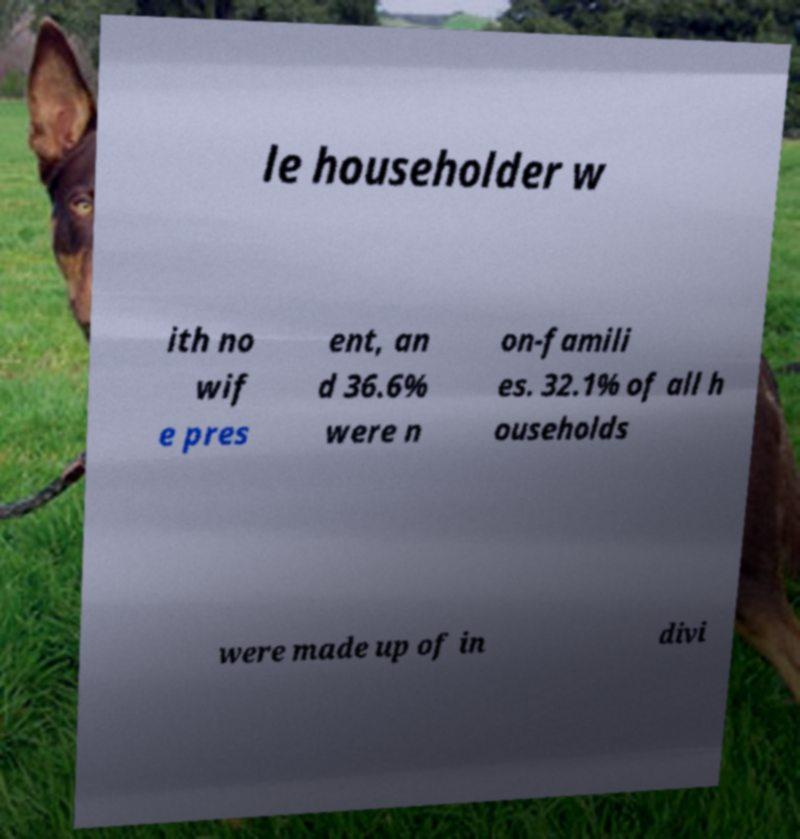There's text embedded in this image that I need extracted. Can you transcribe it verbatim? le householder w ith no wif e pres ent, an d 36.6% were n on-famili es. 32.1% of all h ouseholds were made up of in divi 